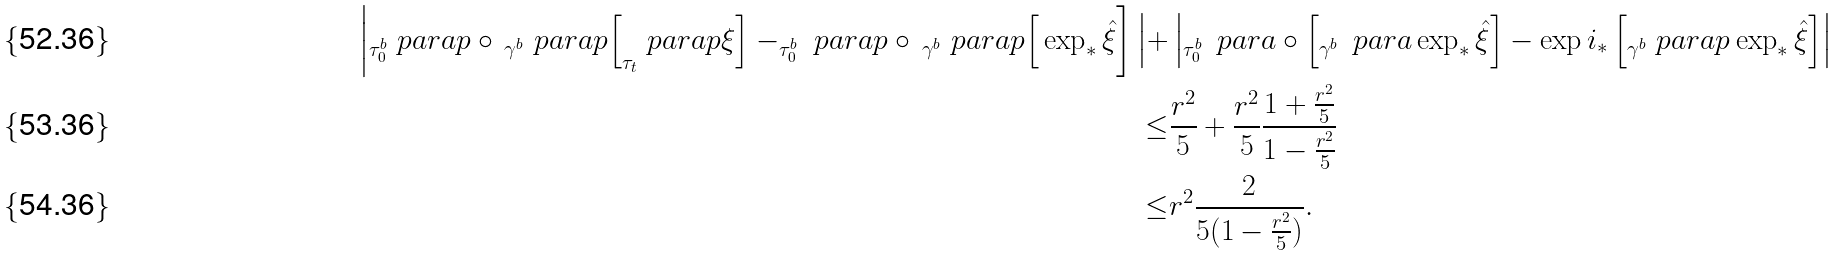Convert formula to latex. <formula><loc_0><loc_0><loc_500><loc_500>\left | _ { \tau _ { 0 } ^ { b } } \ p a r a p \circ \, _ { \gamma ^ { b } } \ p a r a p \Big [ _ { \tau _ { t } } \ p a r a p \xi \Big ] - _ { \tau _ { 0 } ^ { b } } \ p a r a p \circ \, _ { \gamma ^ { b } } \ p a r a p \Big [ \exp _ { * } \hat { \xi } \right ] \Big | + & \left | _ { \tau _ { 0 } ^ { b } } \, \ p a r a \circ \left [ _ { \gamma ^ { b } } \, \ p a r a \exp _ { * } \hat { \xi } \right ] - \exp i _ { * } \left [ _ { \gamma ^ { b } } \ p a r a p \exp _ { * } \hat { \xi } \right ] \right | \\ \leq & \frac { r ^ { 2 } } { 5 } + \frac { r ^ { 2 } } { 5 } \frac { 1 + \frac { r ^ { 2 } } { 5 } } { 1 - \frac { r ^ { 2 } } { 5 } } \\ \leq & r ^ { 2 } \frac { 2 } { 5 ( 1 - \frac { r ^ { 2 } } { 5 } ) } .</formula> 